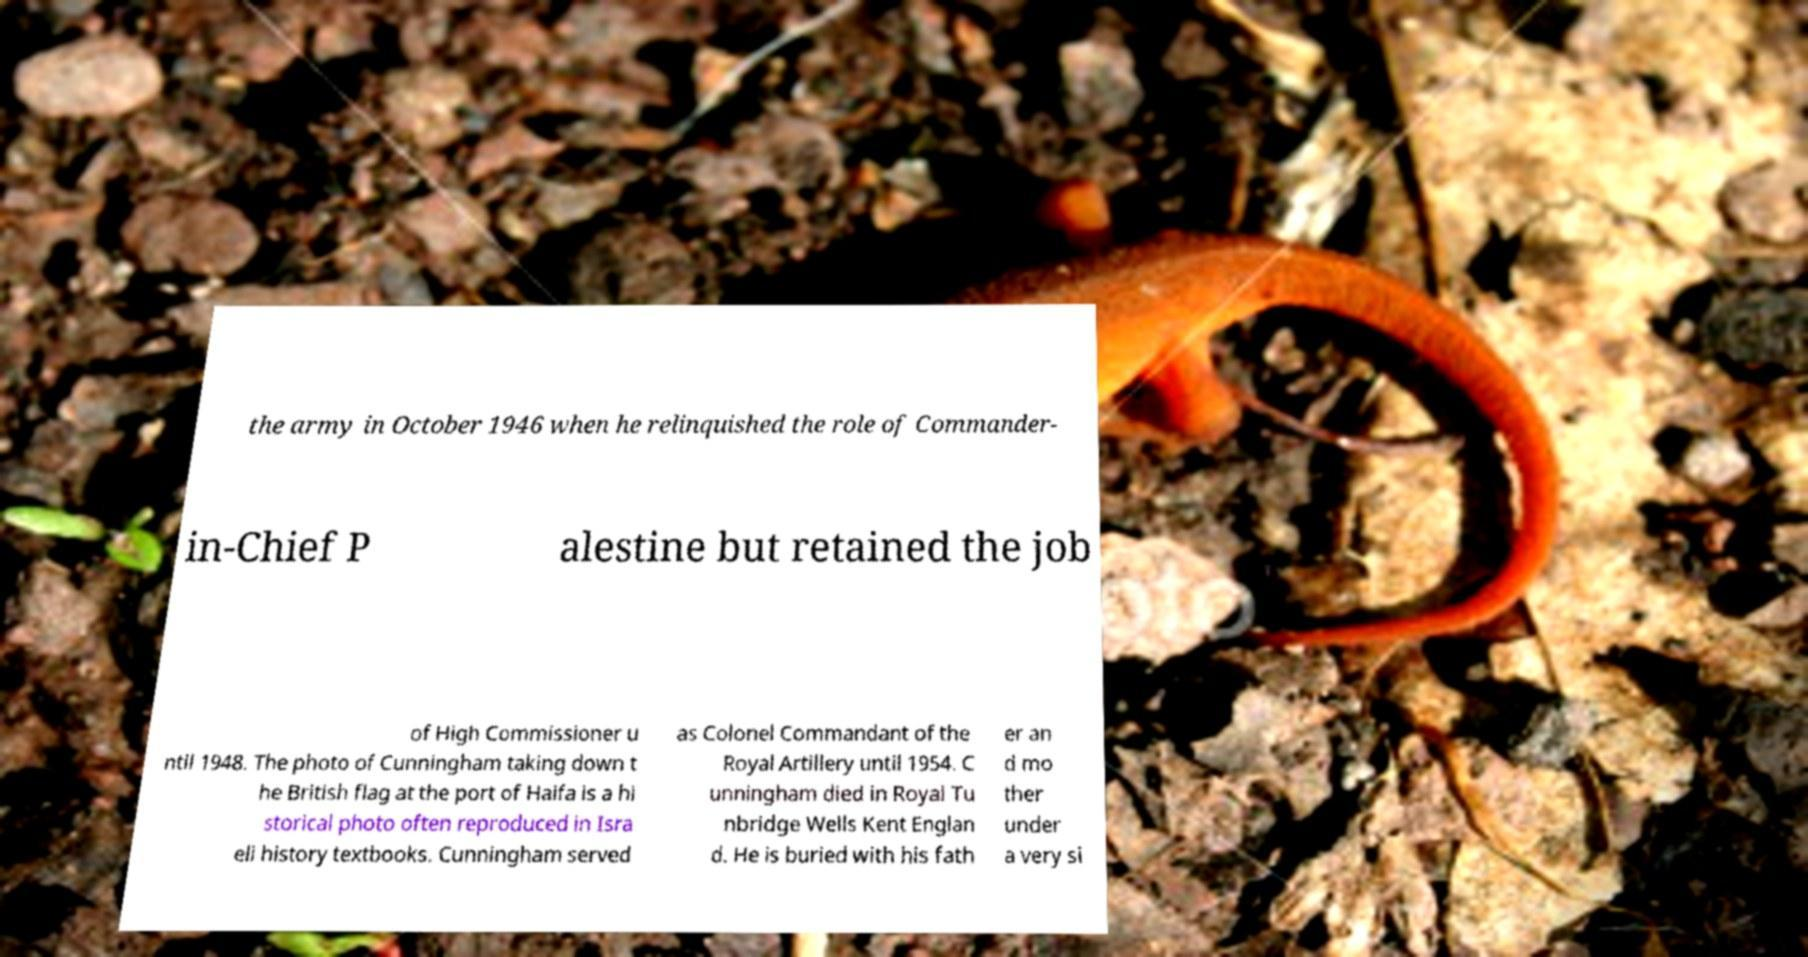Please identify and transcribe the text found in this image. the army in October 1946 when he relinquished the role of Commander- in-Chief P alestine but retained the job of High Commissioner u ntil 1948. The photo of Cunningham taking down t he British flag at the port of Haifa is a hi storical photo often reproduced in Isra eli history textbooks. Cunningham served as Colonel Commandant of the Royal Artillery until 1954. C unningham died in Royal Tu nbridge Wells Kent Englan d. He is buried with his fath er an d mo ther under a very si 